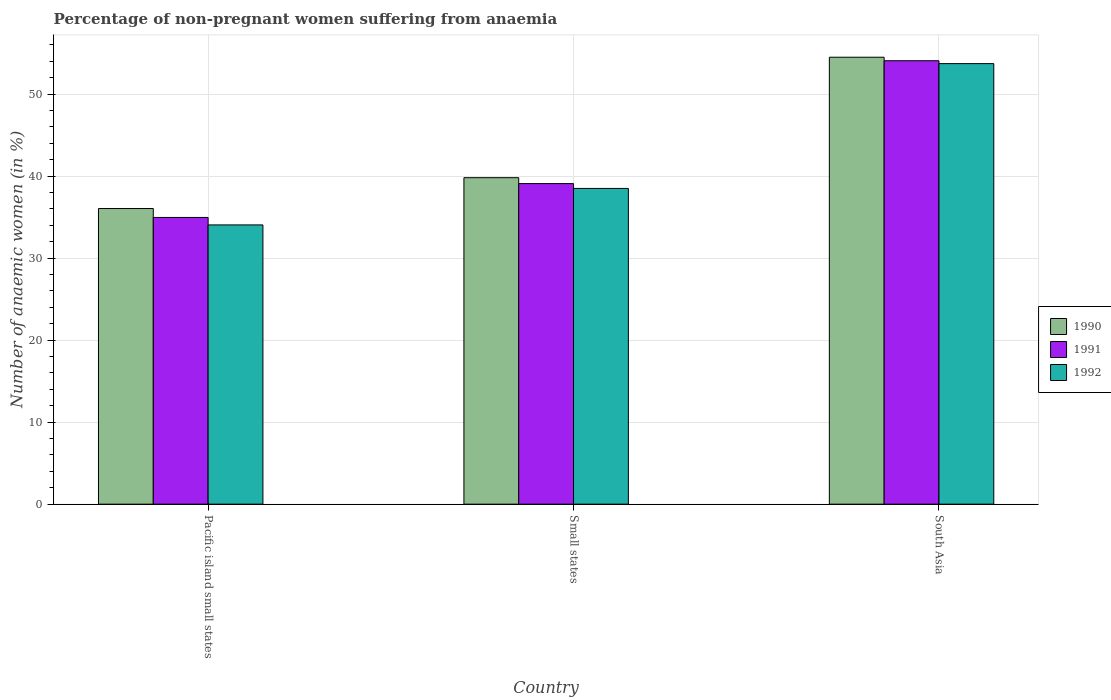How many different coloured bars are there?
Ensure brevity in your answer.  3. How many groups of bars are there?
Provide a short and direct response. 3. Are the number of bars per tick equal to the number of legend labels?
Make the answer very short. Yes. Are the number of bars on each tick of the X-axis equal?
Your answer should be very brief. Yes. How many bars are there on the 1st tick from the right?
Your response must be concise. 3. What is the label of the 3rd group of bars from the left?
Provide a short and direct response. South Asia. In how many cases, is the number of bars for a given country not equal to the number of legend labels?
Offer a terse response. 0. What is the percentage of non-pregnant women suffering from anaemia in 1990 in Small states?
Keep it short and to the point. 39.82. Across all countries, what is the maximum percentage of non-pregnant women suffering from anaemia in 1992?
Keep it short and to the point. 53.73. Across all countries, what is the minimum percentage of non-pregnant women suffering from anaemia in 1991?
Offer a very short reply. 34.97. In which country was the percentage of non-pregnant women suffering from anaemia in 1991 maximum?
Your answer should be compact. South Asia. In which country was the percentage of non-pregnant women suffering from anaemia in 1991 minimum?
Your answer should be very brief. Pacific island small states. What is the total percentage of non-pregnant women suffering from anaemia in 1990 in the graph?
Your answer should be very brief. 130.38. What is the difference between the percentage of non-pregnant women suffering from anaemia in 1990 in Pacific island small states and that in Small states?
Make the answer very short. -3.76. What is the difference between the percentage of non-pregnant women suffering from anaemia in 1992 in Pacific island small states and the percentage of non-pregnant women suffering from anaemia in 1991 in South Asia?
Your answer should be compact. -20.02. What is the average percentage of non-pregnant women suffering from anaemia in 1991 per country?
Keep it short and to the point. 42.71. What is the difference between the percentage of non-pregnant women suffering from anaemia of/in 1990 and percentage of non-pregnant women suffering from anaemia of/in 1991 in Small states?
Provide a succinct answer. 0.72. What is the ratio of the percentage of non-pregnant women suffering from anaemia in 1991 in Pacific island small states to that in South Asia?
Give a very brief answer. 0.65. Is the difference between the percentage of non-pregnant women suffering from anaemia in 1990 in Pacific island small states and Small states greater than the difference between the percentage of non-pregnant women suffering from anaemia in 1991 in Pacific island small states and Small states?
Your response must be concise. Yes. What is the difference between the highest and the second highest percentage of non-pregnant women suffering from anaemia in 1992?
Your answer should be compact. -19.67. What is the difference between the highest and the lowest percentage of non-pregnant women suffering from anaemia in 1991?
Your response must be concise. 19.11. Is the sum of the percentage of non-pregnant women suffering from anaemia in 1991 in Pacific island small states and Small states greater than the maximum percentage of non-pregnant women suffering from anaemia in 1990 across all countries?
Give a very brief answer. Yes. Are all the bars in the graph horizontal?
Offer a terse response. No. What is the difference between two consecutive major ticks on the Y-axis?
Make the answer very short. 10. Are the values on the major ticks of Y-axis written in scientific E-notation?
Provide a succinct answer. No. Does the graph contain any zero values?
Your response must be concise. No. Does the graph contain grids?
Provide a short and direct response. Yes. How many legend labels are there?
Offer a terse response. 3. What is the title of the graph?
Your response must be concise. Percentage of non-pregnant women suffering from anaemia. What is the label or title of the X-axis?
Offer a very short reply. Country. What is the label or title of the Y-axis?
Make the answer very short. Number of anaemic women (in %). What is the Number of anaemic women (in %) in 1990 in Pacific island small states?
Ensure brevity in your answer.  36.06. What is the Number of anaemic women (in %) in 1991 in Pacific island small states?
Provide a succinct answer. 34.97. What is the Number of anaemic women (in %) of 1992 in Pacific island small states?
Offer a terse response. 34.06. What is the Number of anaemic women (in %) in 1990 in Small states?
Your answer should be very brief. 39.82. What is the Number of anaemic women (in %) of 1991 in Small states?
Your response must be concise. 39.1. What is the Number of anaemic women (in %) of 1992 in Small states?
Make the answer very short. 38.51. What is the Number of anaemic women (in %) of 1990 in South Asia?
Give a very brief answer. 54.51. What is the Number of anaemic women (in %) of 1991 in South Asia?
Your answer should be very brief. 54.08. What is the Number of anaemic women (in %) in 1992 in South Asia?
Offer a terse response. 53.73. Across all countries, what is the maximum Number of anaemic women (in %) in 1990?
Make the answer very short. 54.51. Across all countries, what is the maximum Number of anaemic women (in %) in 1991?
Your answer should be very brief. 54.08. Across all countries, what is the maximum Number of anaemic women (in %) in 1992?
Your response must be concise. 53.73. Across all countries, what is the minimum Number of anaemic women (in %) of 1990?
Keep it short and to the point. 36.06. Across all countries, what is the minimum Number of anaemic women (in %) in 1991?
Offer a terse response. 34.97. Across all countries, what is the minimum Number of anaemic women (in %) of 1992?
Offer a terse response. 34.06. What is the total Number of anaemic women (in %) of 1990 in the graph?
Your response must be concise. 130.38. What is the total Number of anaemic women (in %) of 1991 in the graph?
Provide a short and direct response. 128.14. What is the total Number of anaemic women (in %) of 1992 in the graph?
Keep it short and to the point. 126.29. What is the difference between the Number of anaemic women (in %) of 1990 in Pacific island small states and that in Small states?
Your response must be concise. -3.76. What is the difference between the Number of anaemic women (in %) of 1991 in Pacific island small states and that in Small states?
Provide a short and direct response. -4.13. What is the difference between the Number of anaemic women (in %) in 1992 in Pacific island small states and that in Small states?
Give a very brief answer. -4.45. What is the difference between the Number of anaemic women (in %) in 1990 in Pacific island small states and that in South Asia?
Your response must be concise. -18.45. What is the difference between the Number of anaemic women (in %) of 1991 in Pacific island small states and that in South Asia?
Provide a succinct answer. -19.11. What is the difference between the Number of anaemic women (in %) in 1992 in Pacific island small states and that in South Asia?
Provide a succinct answer. -19.67. What is the difference between the Number of anaemic women (in %) of 1990 in Small states and that in South Asia?
Make the answer very short. -14.69. What is the difference between the Number of anaemic women (in %) in 1991 in Small states and that in South Asia?
Provide a succinct answer. -14.98. What is the difference between the Number of anaemic women (in %) of 1992 in Small states and that in South Asia?
Ensure brevity in your answer.  -15.22. What is the difference between the Number of anaemic women (in %) in 1990 in Pacific island small states and the Number of anaemic women (in %) in 1991 in Small states?
Offer a terse response. -3.04. What is the difference between the Number of anaemic women (in %) in 1990 in Pacific island small states and the Number of anaemic women (in %) in 1992 in Small states?
Your response must be concise. -2.45. What is the difference between the Number of anaemic women (in %) of 1991 in Pacific island small states and the Number of anaemic women (in %) of 1992 in Small states?
Keep it short and to the point. -3.54. What is the difference between the Number of anaemic women (in %) in 1990 in Pacific island small states and the Number of anaemic women (in %) in 1991 in South Asia?
Offer a terse response. -18.02. What is the difference between the Number of anaemic women (in %) of 1990 in Pacific island small states and the Number of anaemic women (in %) of 1992 in South Asia?
Your answer should be very brief. -17.67. What is the difference between the Number of anaemic women (in %) in 1991 in Pacific island small states and the Number of anaemic women (in %) in 1992 in South Asia?
Make the answer very short. -18.76. What is the difference between the Number of anaemic women (in %) of 1990 in Small states and the Number of anaemic women (in %) of 1991 in South Asia?
Your response must be concise. -14.26. What is the difference between the Number of anaemic women (in %) in 1990 in Small states and the Number of anaemic women (in %) in 1992 in South Asia?
Provide a short and direct response. -13.91. What is the difference between the Number of anaemic women (in %) of 1991 in Small states and the Number of anaemic women (in %) of 1992 in South Asia?
Offer a very short reply. -14.63. What is the average Number of anaemic women (in %) in 1990 per country?
Offer a very short reply. 43.46. What is the average Number of anaemic women (in %) of 1991 per country?
Your answer should be very brief. 42.71. What is the average Number of anaemic women (in %) of 1992 per country?
Your answer should be compact. 42.1. What is the difference between the Number of anaemic women (in %) of 1990 and Number of anaemic women (in %) of 1991 in Pacific island small states?
Your answer should be very brief. 1.09. What is the difference between the Number of anaemic women (in %) of 1990 and Number of anaemic women (in %) of 1992 in Pacific island small states?
Your answer should be very brief. 2. What is the difference between the Number of anaemic women (in %) of 1991 and Number of anaemic women (in %) of 1992 in Pacific island small states?
Give a very brief answer. 0.91. What is the difference between the Number of anaemic women (in %) in 1990 and Number of anaemic women (in %) in 1991 in Small states?
Provide a short and direct response. 0.72. What is the difference between the Number of anaemic women (in %) in 1990 and Number of anaemic women (in %) in 1992 in Small states?
Provide a succinct answer. 1.31. What is the difference between the Number of anaemic women (in %) in 1991 and Number of anaemic women (in %) in 1992 in Small states?
Keep it short and to the point. 0.59. What is the difference between the Number of anaemic women (in %) in 1990 and Number of anaemic women (in %) in 1991 in South Asia?
Your response must be concise. 0.43. What is the difference between the Number of anaemic women (in %) in 1990 and Number of anaemic women (in %) in 1992 in South Asia?
Your answer should be very brief. 0.78. What is the difference between the Number of anaemic women (in %) of 1991 and Number of anaemic women (in %) of 1992 in South Asia?
Your answer should be compact. 0.35. What is the ratio of the Number of anaemic women (in %) of 1990 in Pacific island small states to that in Small states?
Give a very brief answer. 0.91. What is the ratio of the Number of anaemic women (in %) of 1991 in Pacific island small states to that in Small states?
Ensure brevity in your answer.  0.89. What is the ratio of the Number of anaemic women (in %) in 1992 in Pacific island small states to that in Small states?
Keep it short and to the point. 0.88. What is the ratio of the Number of anaemic women (in %) of 1990 in Pacific island small states to that in South Asia?
Your response must be concise. 0.66. What is the ratio of the Number of anaemic women (in %) of 1991 in Pacific island small states to that in South Asia?
Offer a terse response. 0.65. What is the ratio of the Number of anaemic women (in %) of 1992 in Pacific island small states to that in South Asia?
Ensure brevity in your answer.  0.63. What is the ratio of the Number of anaemic women (in %) in 1990 in Small states to that in South Asia?
Your answer should be compact. 0.73. What is the ratio of the Number of anaemic women (in %) in 1991 in Small states to that in South Asia?
Keep it short and to the point. 0.72. What is the ratio of the Number of anaemic women (in %) in 1992 in Small states to that in South Asia?
Offer a terse response. 0.72. What is the difference between the highest and the second highest Number of anaemic women (in %) of 1990?
Provide a succinct answer. 14.69. What is the difference between the highest and the second highest Number of anaemic women (in %) in 1991?
Give a very brief answer. 14.98. What is the difference between the highest and the second highest Number of anaemic women (in %) of 1992?
Your answer should be very brief. 15.22. What is the difference between the highest and the lowest Number of anaemic women (in %) of 1990?
Your response must be concise. 18.45. What is the difference between the highest and the lowest Number of anaemic women (in %) in 1991?
Make the answer very short. 19.11. What is the difference between the highest and the lowest Number of anaemic women (in %) of 1992?
Provide a short and direct response. 19.67. 